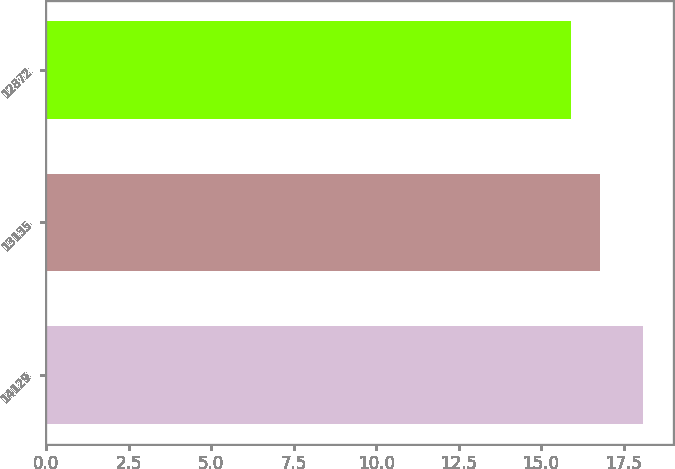Convert chart to OTSL. <chart><loc_0><loc_0><loc_500><loc_500><bar_chart><fcel>14129<fcel>13135<fcel>12872<nl><fcel>18.1<fcel>16.8<fcel>15.9<nl></chart> 